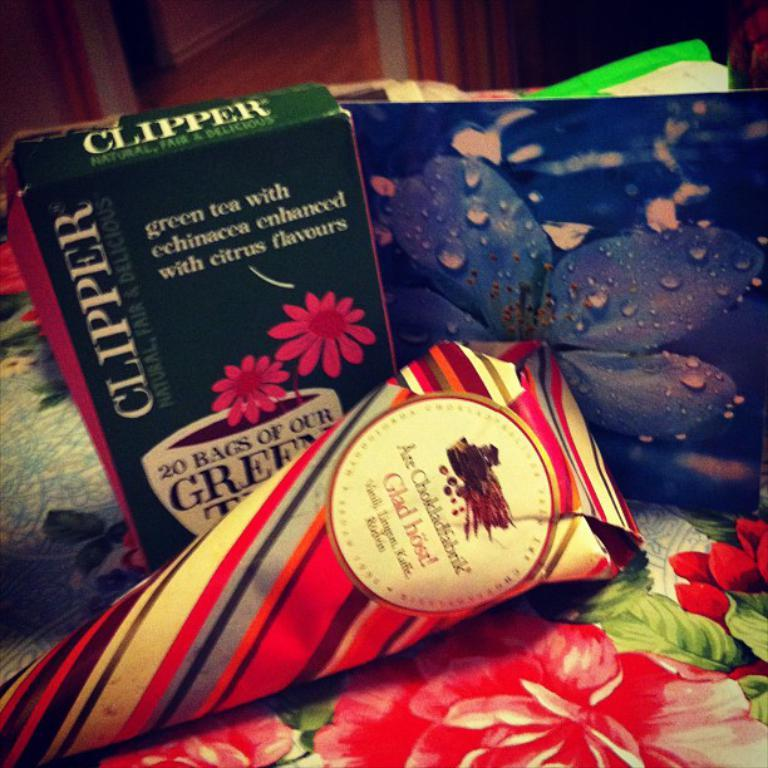Provide a one-sentence caption for the provided image. a box of Clipper green tea sits on a table next to a picture of a blue flower. 